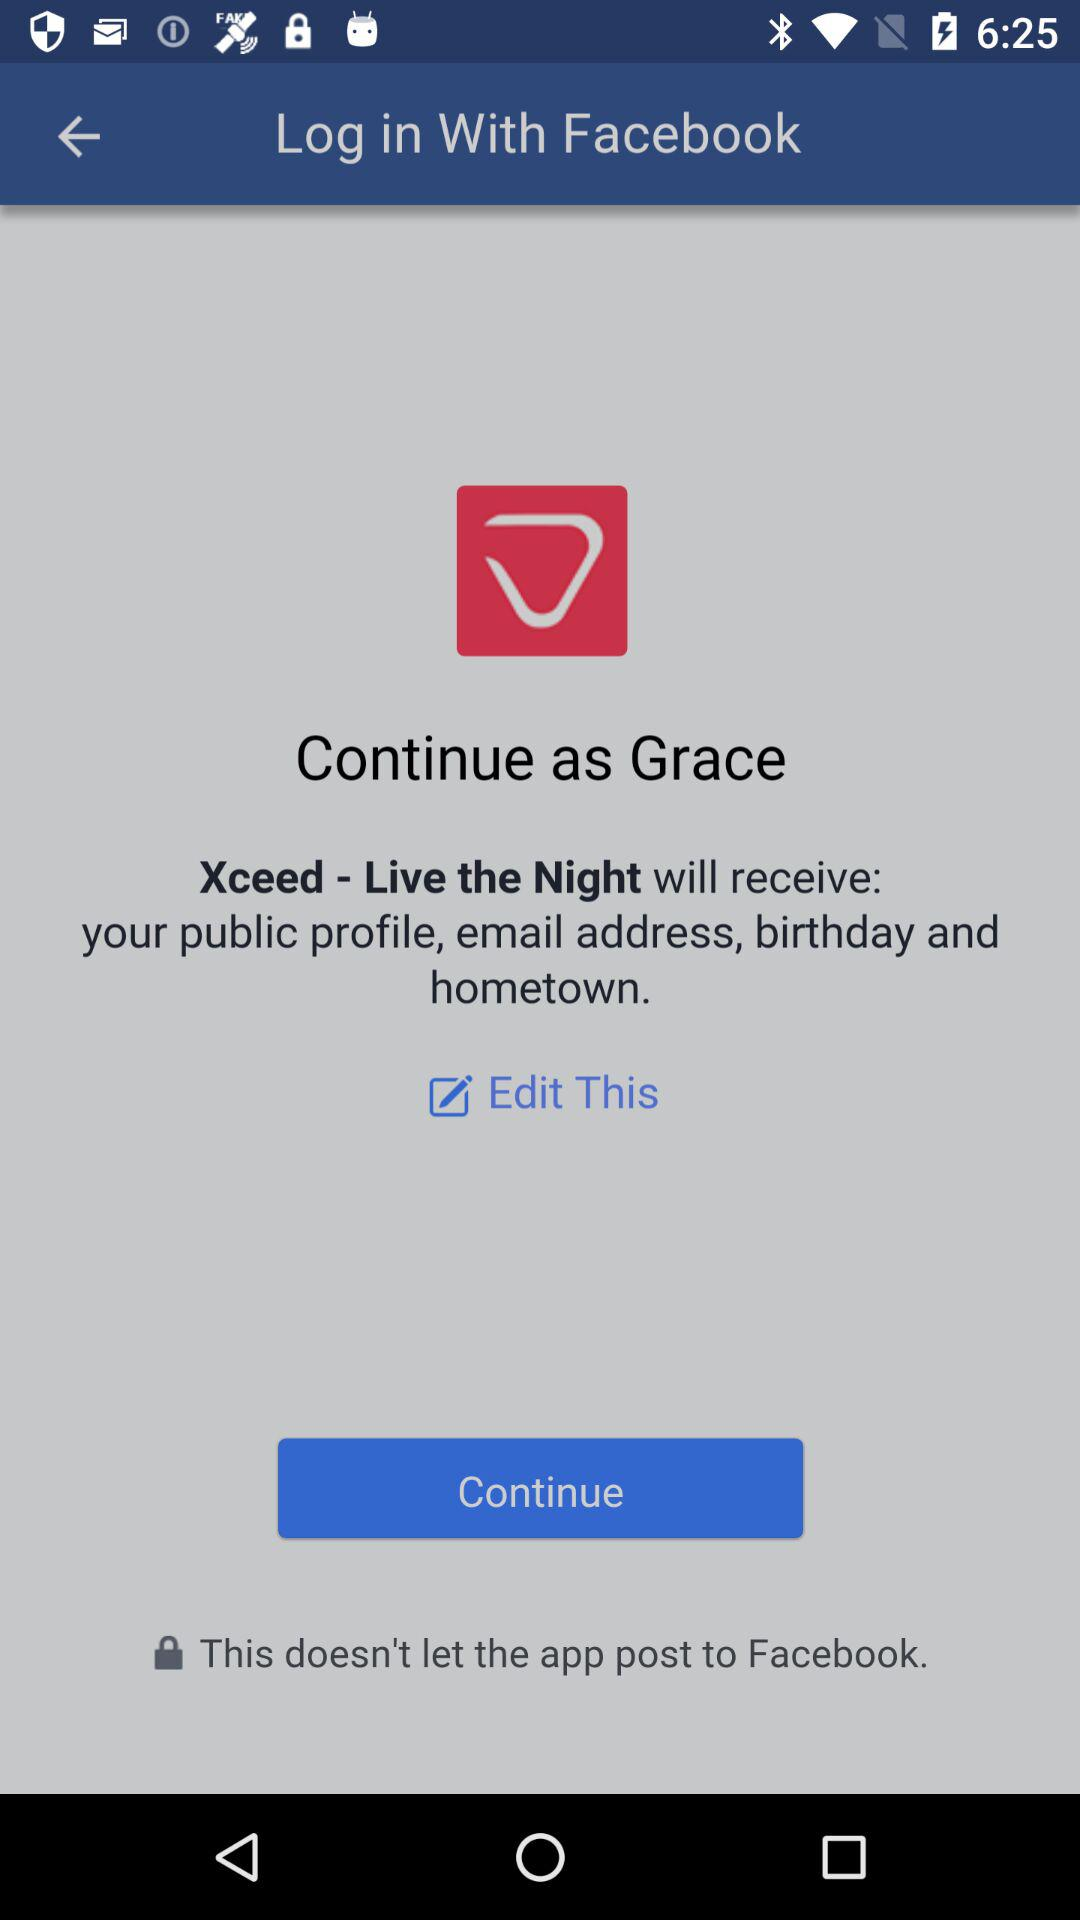What application is asking for permission? The application asking for permission is "Xceed - Live the Night". 